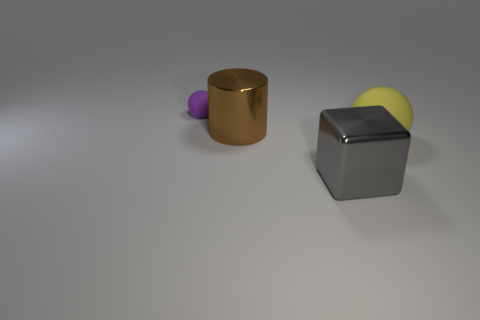Add 4 large green rubber cylinders. How many objects exist? 8 Subtract all cylinders. How many objects are left? 3 Add 2 tiny purple rubber objects. How many tiny purple rubber objects exist? 3 Subtract 0 cyan cubes. How many objects are left? 4 Subtract all brown matte balls. Subtract all big shiny objects. How many objects are left? 2 Add 3 purple rubber objects. How many purple rubber objects are left? 4 